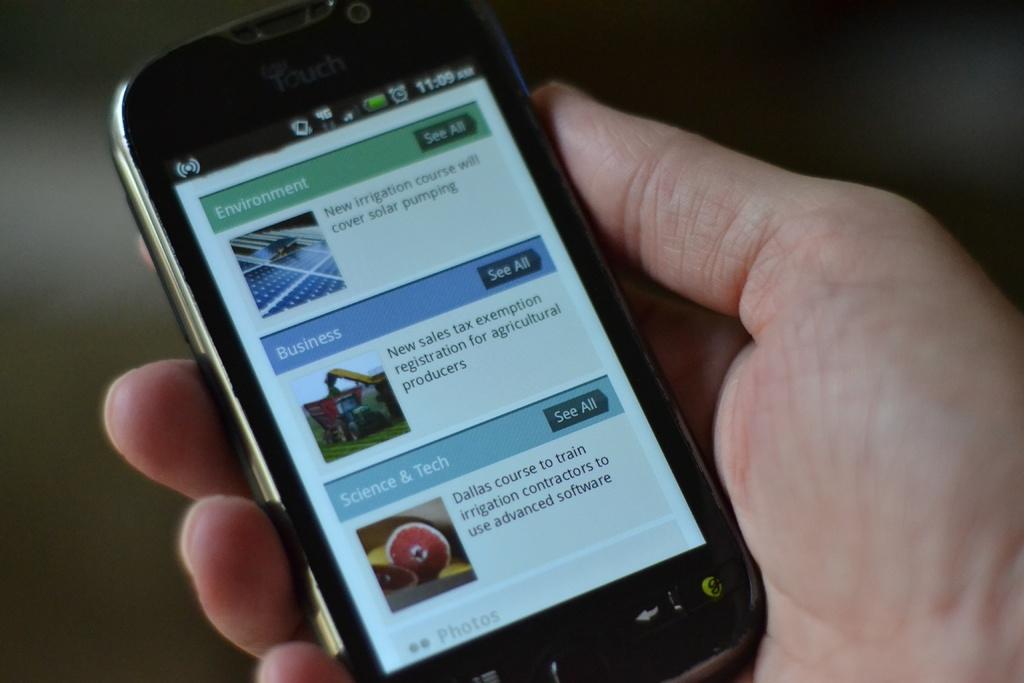What is the middle news category?
Give a very brief answer. Business. What time does the phone say on the screen?
Ensure brevity in your answer.  11:09. 